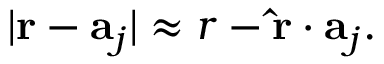Convert formula to latex. <formula><loc_0><loc_0><loc_500><loc_500>| r - a _ { j } | \approx r - \hat { r } \cdot a _ { j } .</formula> 